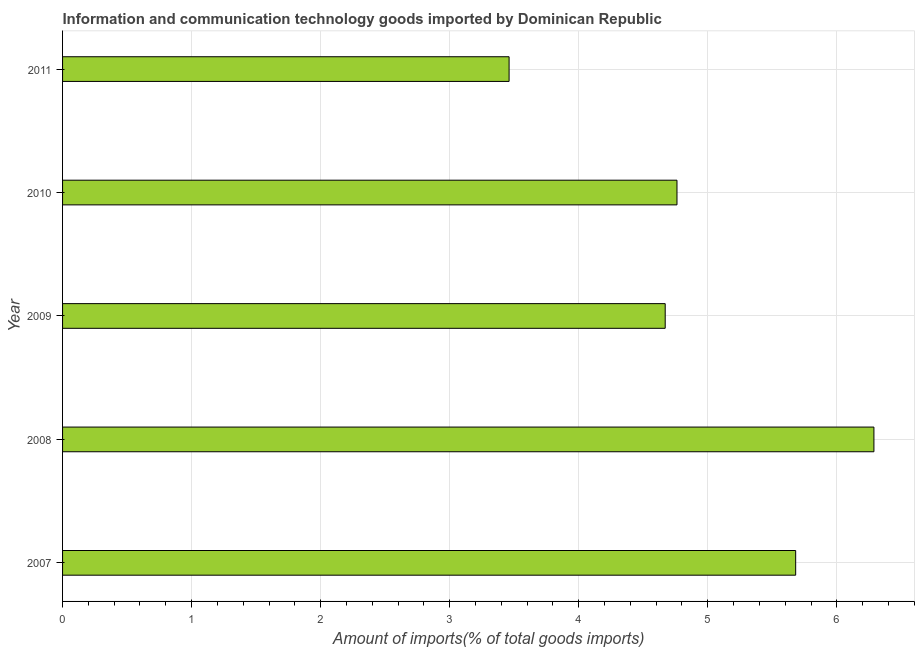What is the title of the graph?
Make the answer very short. Information and communication technology goods imported by Dominican Republic. What is the label or title of the X-axis?
Your answer should be very brief. Amount of imports(% of total goods imports). What is the label or title of the Y-axis?
Give a very brief answer. Year. What is the amount of ict goods imports in 2008?
Give a very brief answer. 6.29. Across all years, what is the maximum amount of ict goods imports?
Ensure brevity in your answer.  6.29. Across all years, what is the minimum amount of ict goods imports?
Offer a terse response. 3.46. In which year was the amount of ict goods imports maximum?
Keep it short and to the point. 2008. In which year was the amount of ict goods imports minimum?
Your answer should be very brief. 2011. What is the sum of the amount of ict goods imports?
Offer a very short reply. 24.86. What is the difference between the amount of ict goods imports in 2008 and 2010?
Keep it short and to the point. 1.53. What is the average amount of ict goods imports per year?
Your answer should be compact. 4.97. What is the median amount of ict goods imports?
Ensure brevity in your answer.  4.76. What is the ratio of the amount of ict goods imports in 2007 to that in 2010?
Offer a very short reply. 1.19. Is the amount of ict goods imports in 2008 less than that in 2010?
Offer a terse response. No. Is the difference between the amount of ict goods imports in 2009 and 2010 greater than the difference between any two years?
Ensure brevity in your answer.  No. What is the difference between the highest and the second highest amount of ict goods imports?
Provide a succinct answer. 0.61. Is the sum of the amount of ict goods imports in 2008 and 2011 greater than the maximum amount of ict goods imports across all years?
Provide a short and direct response. Yes. What is the difference between the highest and the lowest amount of ict goods imports?
Your answer should be compact. 2.83. How many bars are there?
Give a very brief answer. 5. What is the difference between two consecutive major ticks on the X-axis?
Ensure brevity in your answer.  1. What is the Amount of imports(% of total goods imports) of 2007?
Provide a succinct answer. 5.68. What is the Amount of imports(% of total goods imports) of 2008?
Your answer should be very brief. 6.29. What is the Amount of imports(% of total goods imports) of 2009?
Your answer should be very brief. 4.67. What is the Amount of imports(% of total goods imports) in 2010?
Offer a terse response. 4.76. What is the Amount of imports(% of total goods imports) of 2011?
Keep it short and to the point. 3.46. What is the difference between the Amount of imports(% of total goods imports) in 2007 and 2008?
Your response must be concise. -0.61. What is the difference between the Amount of imports(% of total goods imports) in 2007 and 2009?
Ensure brevity in your answer.  1.01. What is the difference between the Amount of imports(% of total goods imports) in 2007 and 2010?
Your answer should be compact. 0.92. What is the difference between the Amount of imports(% of total goods imports) in 2007 and 2011?
Your response must be concise. 2.22. What is the difference between the Amount of imports(% of total goods imports) in 2008 and 2009?
Offer a terse response. 1.62. What is the difference between the Amount of imports(% of total goods imports) in 2008 and 2010?
Your response must be concise. 1.53. What is the difference between the Amount of imports(% of total goods imports) in 2008 and 2011?
Provide a short and direct response. 2.83. What is the difference between the Amount of imports(% of total goods imports) in 2009 and 2010?
Ensure brevity in your answer.  -0.09. What is the difference between the Amount of imports(% of total goods imports) in 2009 and 2011?
Make the answer very short. 1.21. What is the difference between the Amount of imports(% of total goods imports) in 2010 and 2011?
Offer a terse response. 1.3. What is the ratio of the Amount of imports(% of total goods imports) in 2007 to that in 2008?
Give a very brief answer. 0.9. What is the ratio of the Amount of imports(% of total goods imports) in 2007 to that in 2009?
Provide a succinct answer. 1.22. What is the ratio of the Amount of imports(% of total goods imports) in 2007 to that in 2010?
Provide a succinct answer. 1.19. What is the ratio of the Amount of imports(% of total goods imports) in 2007 to that in 2011?
Offer a very short reply. 1.64. What is the ratio of the Amount of imports(% of total goods imports) in 2008 to that in 2009?
Provide a short and direct response. 1.35. What is the ratio of the Amount of imports(% of total goods imports) in 2008 to that in 2010?
Provide a succinct answer. 1.32. What is the ratio of the Amount of imports(% of total goods imports) in 2008 to that in 2011?
Give a very brief answer. 1.82. What is the ratio of the Amount of imports(% of total goods imports) in 2009 to that in 2011?
Your response must be concise. 1.35. What is the ratio of the Amount of imports(% of total goods imports) in 2010 to that in 2011?
Your answer should be very brief. 1.38. 